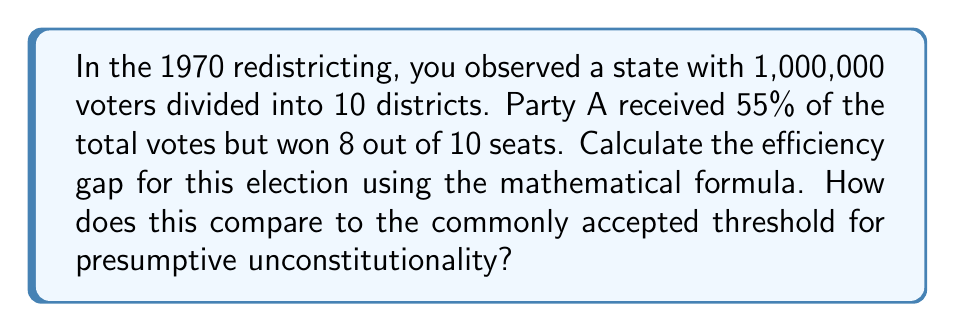Provide a solution to this math problem. To calculate the efficiency gap, we'll use the formula:

$$ \text{Efficiency Gap} = \frac{\text{Wasted Votes}_A - \text{Wasted Votes}_B}{\text{Total Votes}} $$

Where wasted votes are:
- All votes cast for the losing candidate
- All votes cast for the winning candidate in excess of the 50% + 1 needed to win

Step 1: Calculate total votes for each party
- Total votes: 1,000,000
- Party A votes: 55% of 1,000,000 = 550,000
- Party B votes: 45% of 1,000,000 = 450,000

Step 2: Calculate votes per district
- Votes per district: 1,000,000 ÷ 10 = 100,000

Step 3: Calculate wasted votes for Party A
- Won 8 districts: 8 × (50,000 - 1) = 399,992
- Lost 2 districts: 2 × 50,000 = 100,000
- Total wasted votes A: 499,992

Step 4: Calculate wasted votes for Party B
- Won 2 districts: 2 × (50,000 - 1) = 99,998
- Lost 8 districts: 8 × 50,000 = 400,000
- Total wasted votes B: 499,998

Step 5: Apply the efficiency gap formula
$$ \text{Efficiency Gap} = \frac{499,992 - 499,998}{1,000,000} = -0.000006 $$

Step 6: Convert to percentage
Efficiency Gap = -0.0006%

The commonly accepted threshold for presumptive unconstitutionality is an efficiency gap of 7% or greater. This result (-0.0006%) is well below that threshold.
Answer: The efficiency gap is -0.0006%, which is significantly below the 7% threshold for presumptive unconstitutionality. 